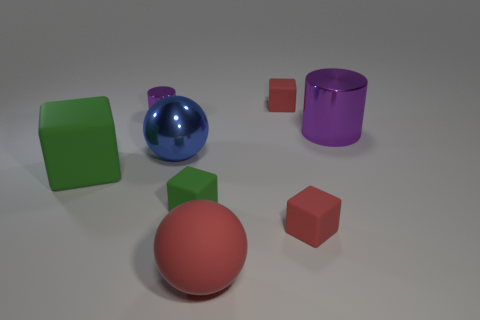Does the big cylinder have the same color as the big matte sphere?
Keep it short and to the point. No. There is a large cube that is made of the same material as the big red thing; what is its color?
Offer a terse response. Green. Does the big rubber object behind the red sphere have the same color as the big metal ball?
Your answer should be very brief. No. There is a purple cylinder that is to the right of the blue shiny sphere; what is it made of?
Make the answer very short. Metal. Are there the same number of small green rubber blocks that are left of the small metal thing and small purple metallic objects?
Your answer should be compact. No. What number of tiny rubber cubes are the same color as the big block?
Offer a terse response. 1. There is a large matte object that is the same shape as the tiny green object; what color is it?
Make the answer very short. Green. Do the blue object and the red matte sphere have the same size?
Provide a short and direct response. Yes. Are there the same number of large red rubber balls that are behind the small purple shiny cylinder and blue metal spheres on the right side of the large green object?
Your response must be concise. No. Is there a large thing?
Make the answer very short. Yes. 